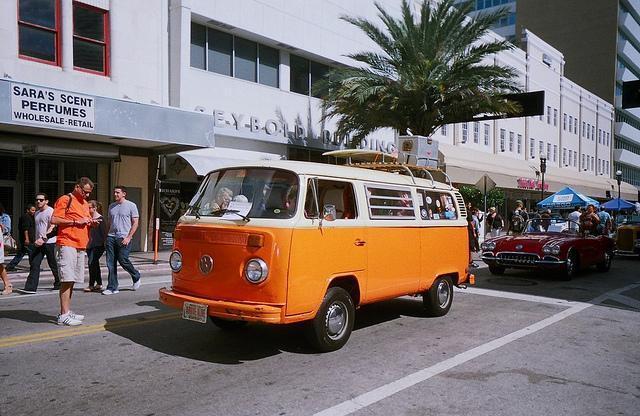How many cars are there?
Give a very brief answer. 2. How many buses can be seen?
Give a very brief answer. 1. How many people can be seen?
Give a very brief answer. 3. 